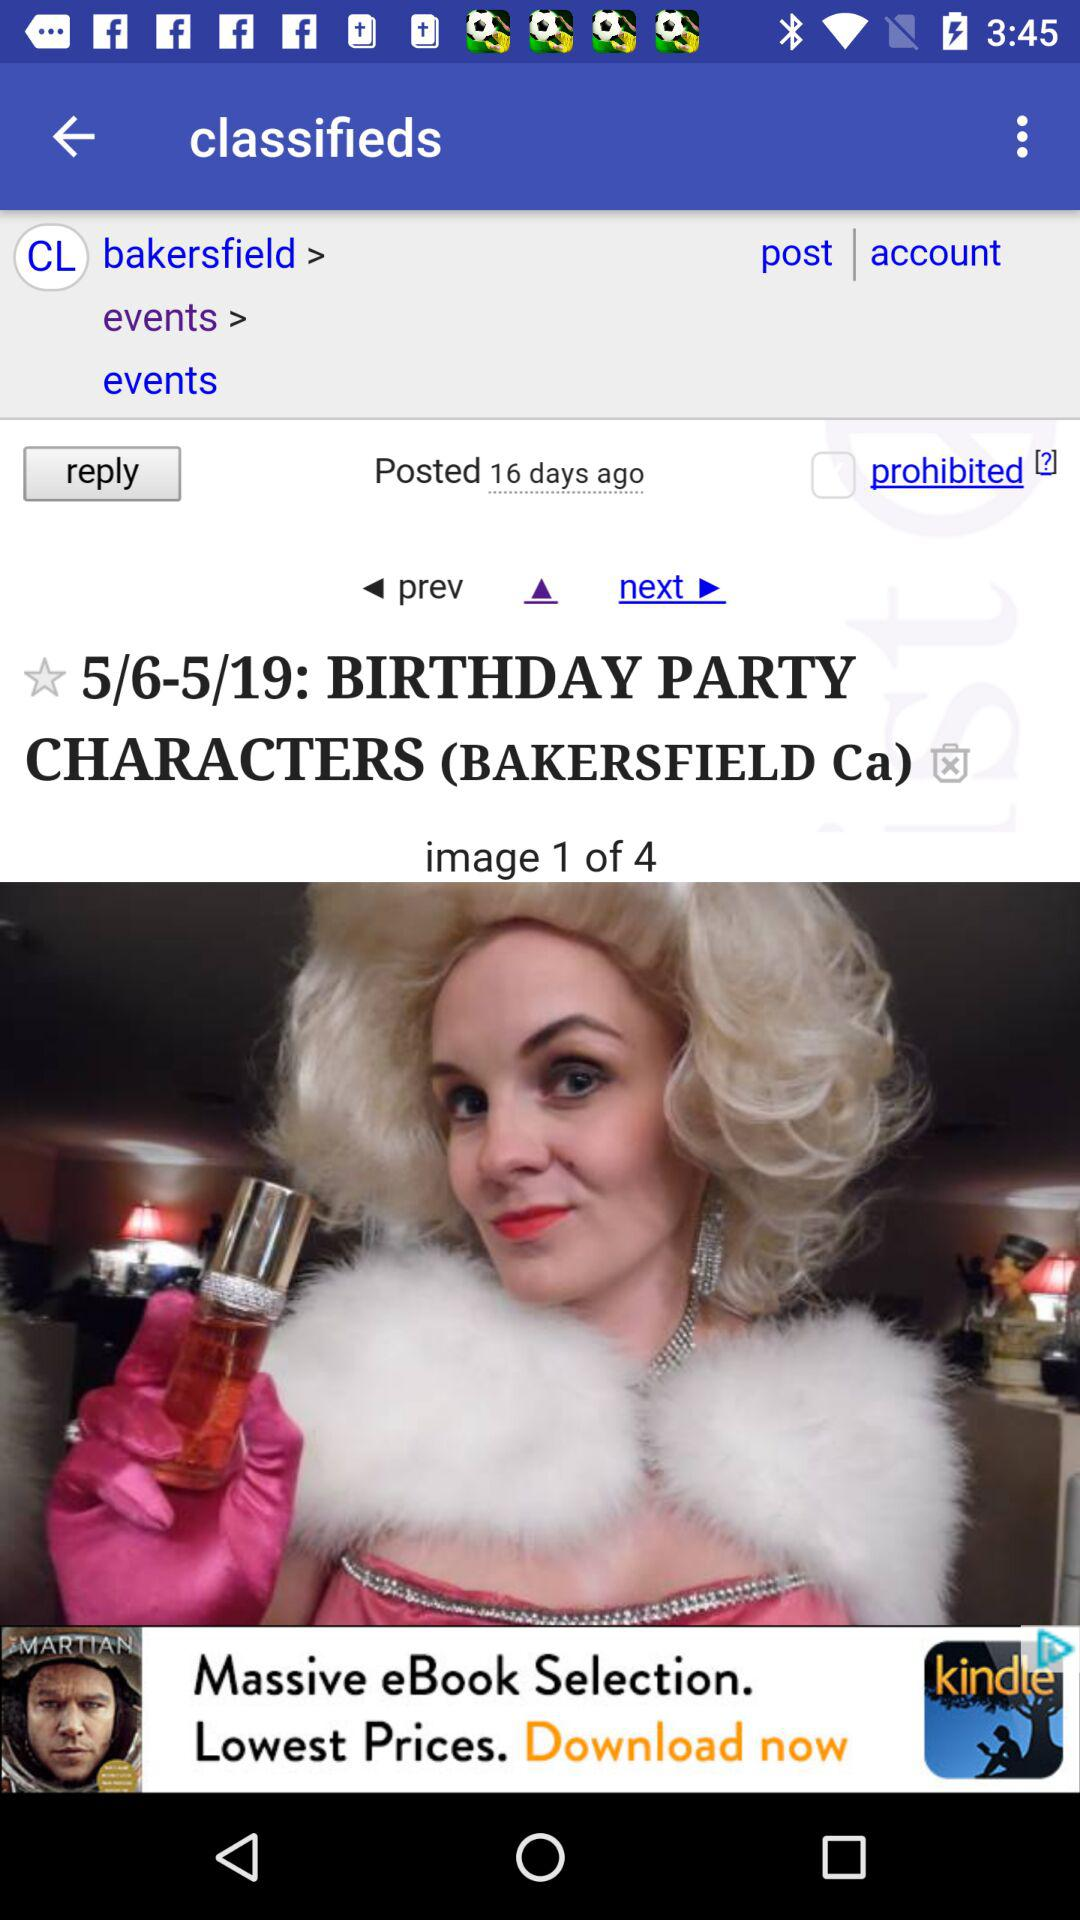When was the last time we posted? You posted 16 days ago. 